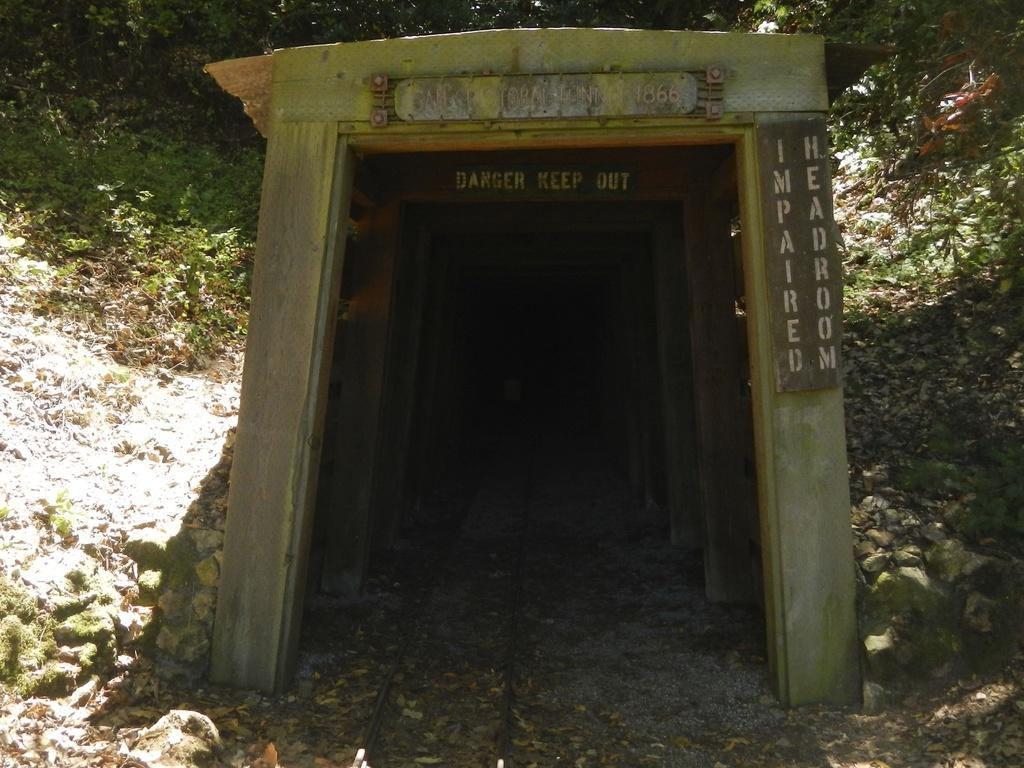What is the main subject in the center of the image? There is a tunnel in the center of the image. What can be seen inside the tunnel? There is a track inside the tunnel. What type of natural elements are visible in the background of the image? There are plants and stones in the background of the image. How many bears are visible inside the tunnel in the image? There are no bears present in the image. What type of tool is being used to construct the tunnel in the image? There is no tool visible in the image, as it is focused on the tunnel and its surroundings. 